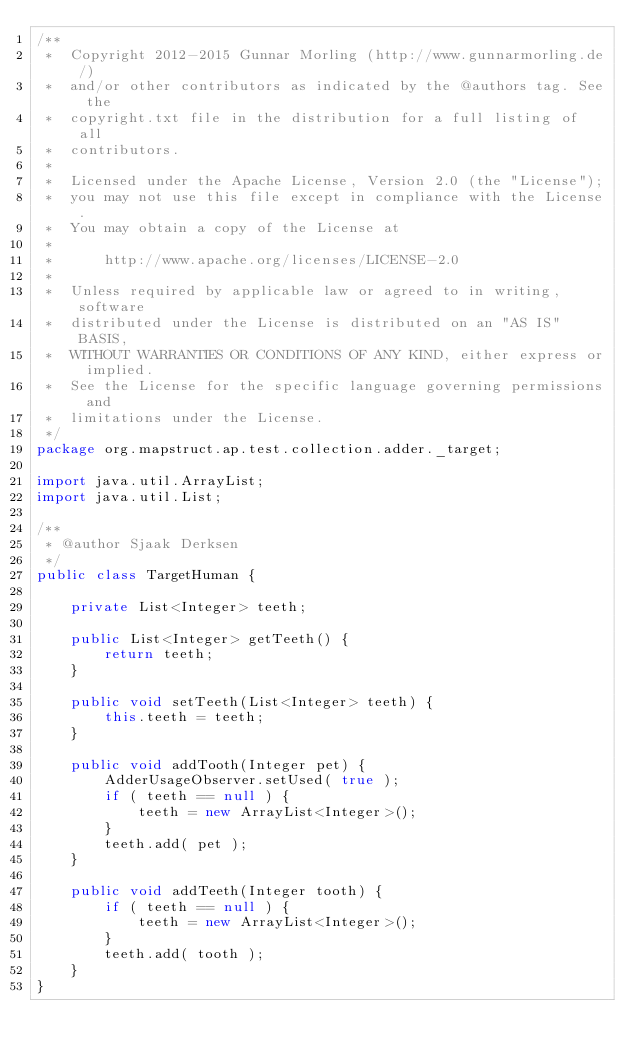Convert code to text. <code><loc_0><loc_0><loc_500><loc_500><_Java_>/**
 *  Copyright 2012-2015 Gunnar Morling (http://www.gunnarmorling.de/)
 *  and/or other contributors as indicated by the @authors tag. See the
 *  copyright.txt file in the distribution for a full listing of all
 *  contributors.
 *
 *  Licensed under the Apache License, Version 2.0 (the "License");
 *  you may not use this file except in compliance with the License.
 *  You may obtain a copy of the License at
 *
 *      http://www.apache.org/licenses/LICENSE-2.0
 *
 *  Unless required by applicable law or agreed to in writing, software
 *  distributed under the License is distributed on an "AS IS" BASIS,
 *  WITHOUT WARRANTIES OR CONDITIONS OF ANY KIND, either express or implied.
 *  See the License for the specific language governing permissions and
 *  limitations under the License.
 */
package org.mapstruct.ap.test.collection.adder._target;

import java.util.ArrayList;
import java.util.List;

/**
 * @author Sjaak Derksen
 */
public class TargetHuman {

    private List<Integer> teeth;

    public List<Integer> getTeeth() {
        return teeth;
    }

    public void setTeeth(List<Integer> teeth) {
        this.teeth = teeth;
    }

    public void addTooth(Integer pet) {
        AdderUsageObserver.setUsed( true );
        if ( teeth == null ) {
            teeth = new ArrayList<Integer>();
        }
        teeth.add( pet );
    }

    public void addTeeth(Integer tooth) {
        if ( teeth == null ) {
            teeth = new ArrayList<Integer>();
        }
        teeth.add( tooth );
    }
}
</code> 